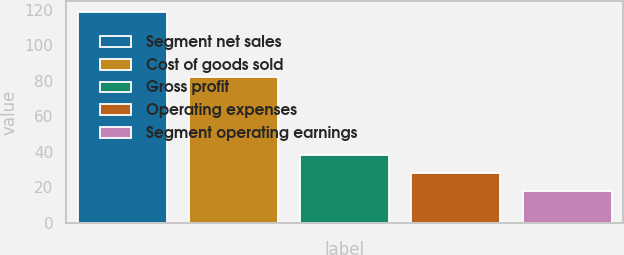Convert chart to OTSL. <chart><loc_0><loc_0><loc_500><loc_500><bar_chart><fcel>Segment net sales<fcel>Cost of goods sold<fcel>Gross profit<fcel>Operating expenses<fcel>Segment operating earnings<nl><fcel>118.6<fcel>81.9<fcel>38.04<fcel>27.97<fcel>17.9<nl></chart> 